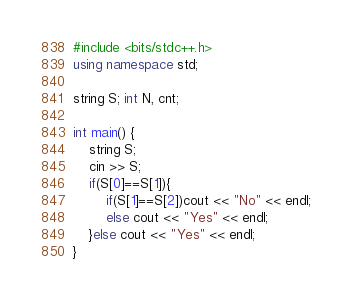<code> <loc_0><loc_0><loc_500><loc_500><_C++_>#include <bits/stdc++.h>
using namespace std;
 
string S; int N, cnt;
 
int main() {
	string S;
    cin >> S;
    if(S[0]==S[1]){
        if(S[1]==S[2])cout << "No" << endl;
        else cout << "Yes" << endl;
    }else cout << "Yes" << endl;
}</code> 